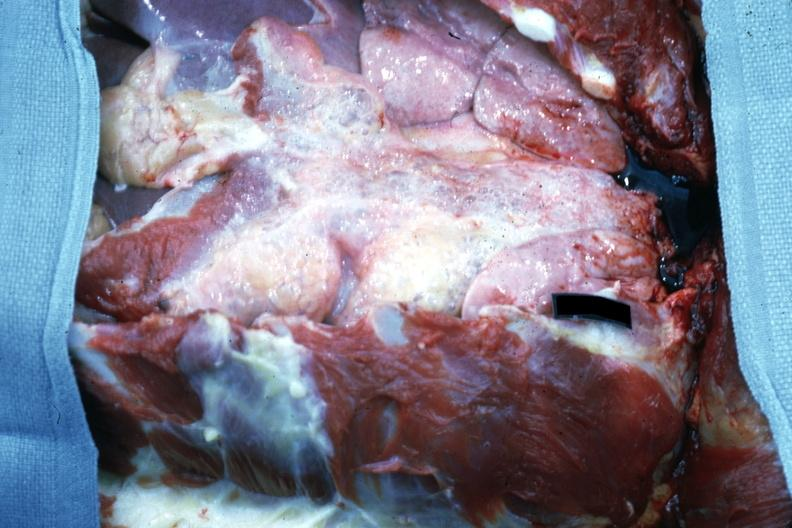s sac removed easily seen air bubbles?
Answer the question using a single word or phrase. No 